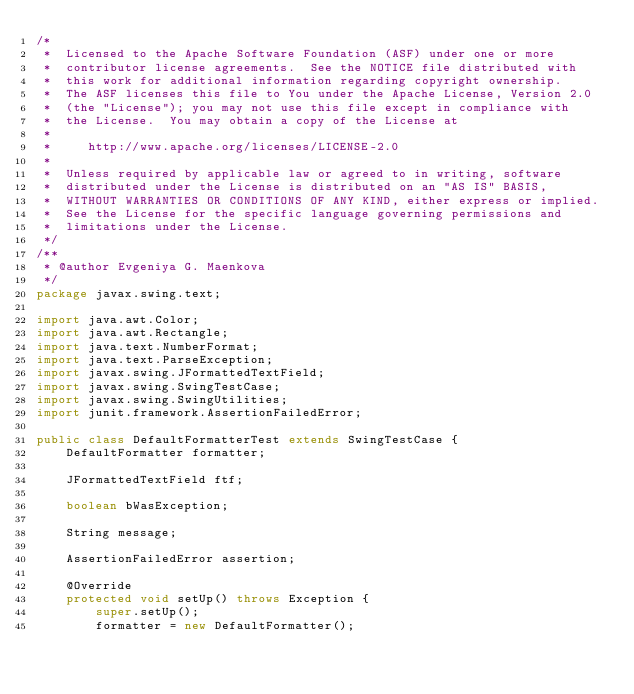Convert code to text. <code><loc_0><loc_0><loc_500><loc_500><_Java_>/*
 *  Licensed to the Apache Software Foundation (ASF) under one or more
 *  contributor license agreements.  See the NOTICE file distributed with
 *  this work for additional information regarding copyright ownership.
 *  The ASF licenses this file to You under the Apache License, Version 2.0
 *  (the "License"); you may not use this file except in compliance with
 *  the License.  You may obtain a copy of the License at
 *
 *     http://www.apache.org/licenses/LICENSE-2.0
 *
 *  Unless required by applicable law or agreed to in writing, software
 *  distributed under the License is distributed on an "AS IS" BASIS,
 *  WITHOUT WARRANTIES OR CONDITIONS OF ANY KIND, either express or implied.
 *  See the License for the specific language governing permissions and
 *  limitations under the License.
 */
/**
 * @author Evgeniya G. Maenkova
 */
package javax.swing.text;

import java.awt.Color;
import java.awt.Rectangle;
import java.text.NumberFormat;
import java.text.ParseException;
import javax.swing.JFormattedTextField;
import javax.swing.SwingTestCase;
import javax.swing.SwingUtilities;
import junit.framework.AssertionFailedError;

public class DefaultFormatterTest extends SwingTestCase {
    DefaultFormatter formatter;

    JFormattedTextField ftf;

    boolean bWasException;

    String message;

    AssertionFailedError assertion;

    @Override
    protected void setUp() throws Exception {
        super.setUp();
        formatter = new DefaultFormatter();</code> 